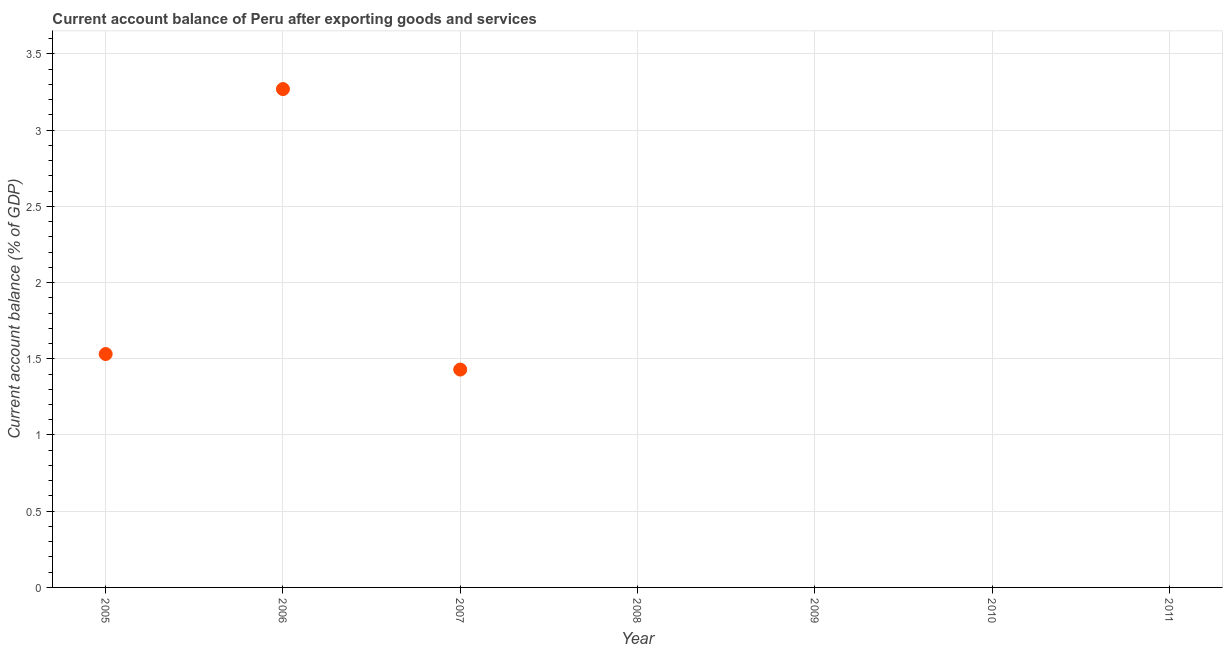What is the current account balance in 2011?
Provide a succinct answer. 0. Across all years, what is the maximum current account balance?
Provide a succinct answer. 3.27. Across all years, what is the minimum current account balance?
Give a very brief answer. 0. What is the sum of the current account balance?
Offer a very short reply. 6.23. What is the difference between the current account balance in 2005 and 2007?
Your answer should be very brief. 0.1. What is the average current account balance per year?
Make the answer very short. 0.89. In how many years, is the current account balance greater than 1.5 %?
Ensure brevity in your answer.  2. What is the ratio of the current account balance in 2005 to that in 2006?
Provide a succinct answer. 0.47. Is the difference between the current account balance in 2005 and 2006 greater than the difference between any two years?
Your answer should be very brief. No. What is the difference between the highest and the second highest current account balance?
Your answer should be compact. 1.74. Is the sum of the current account balance in 2005 and 2007 greater than the maximum current account balance across all years?
Make the answer very short. No. What is the difference between the highest and the lowest current account balance?
Keep it short and to the point. 3.27. In how many years, is the current account balance greater than the average current account balance taken over all years?
Your response must be concise. 3. Does the current account balance monotonically increase over the years?
Offer a very short reply. No. Are the values on the major ticks of Y-axis written in scientific E-notation?
Make the answer very short. No. Does the graph contain any zero values?
Provide a succinct answer. Yes. What is the title of the graph?
Your answer should be compact. Current account balance of Peru after exporting goods and services. What is the label or title of the Y-axis?
Your answer should be compact. Current account balance (% of GDP). What is the Current account balance (% of GDP) in 2005?
Offer a very short reply. 1.53. What is the Current account balance (% of GDP) in 2006?
Offer a very short reply. 3.27. What is the Current account balance (% of GDP) in 2007?
Your answer should be compact. 1.43. What is the Current account balance (% of GDP) in 2009?
Provide a succinct answer. 0. What is the Current account balance (% of GDP) in 2010?
Your answer should be very brief. 0. What is the difference between the Current account balance (% of GDP) in 2005 and 2006?
Offer a very short reply. -1.74. What is the difference between the Current account balance (% of GDP) in 2005 and 2007?
Offer a very short reply. 0.1. What is the difference between the Current account balance (% of GDP) in 2006 and 2007?
Give a very brief answer. 1.84. What is the ratio of the Current account balance (% of GDP) in 2005 to that in 2006?
Offer a very short reply. 0.47. What is the ratio of the Current account balance (% of GDP) in 2005 to that in 2007?
Your response must be concise. 1.07. What is the ratio of the Current account balance (% of GDP) in 2006 to that in 2007?
Ensure brevity in your answer.  2.29. 